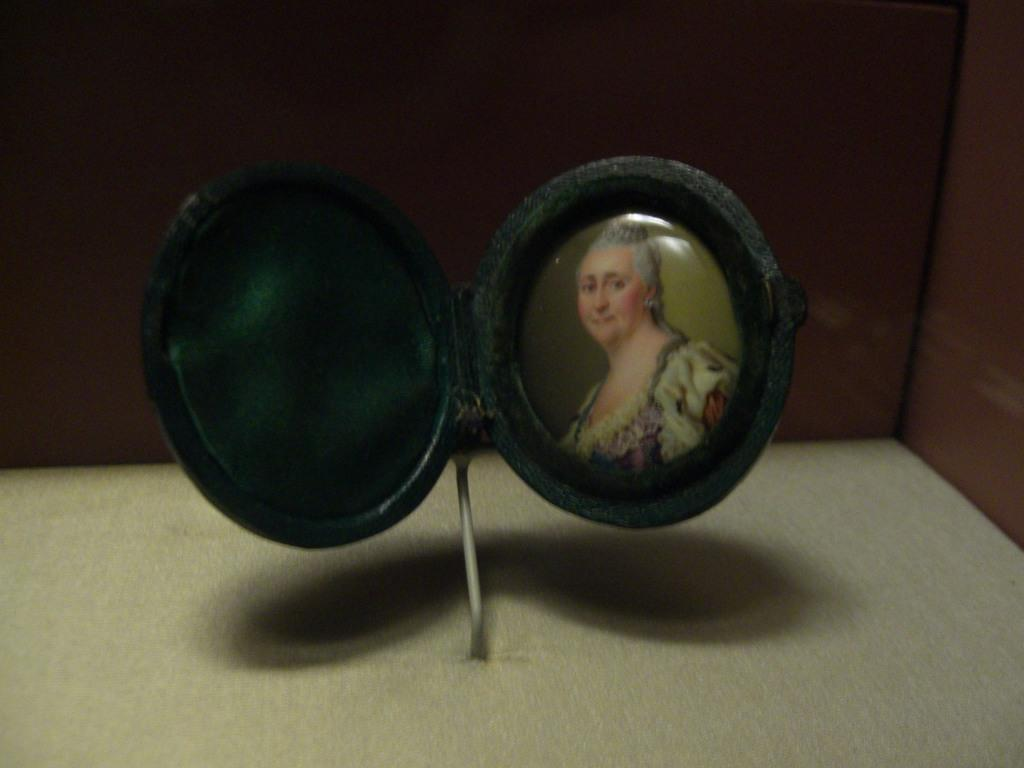What object is present on the floor in the image? There is a photo frame on the floor in the image. What is inside the photo frame? The photo frame contains a photo of a lady. What is behind the photo frame? There is a wall behind the photo frame. What type of music can be heard coming from the window in the image? There is no window present in the image, so it's not possible to determine what, if any, music might be heard. 